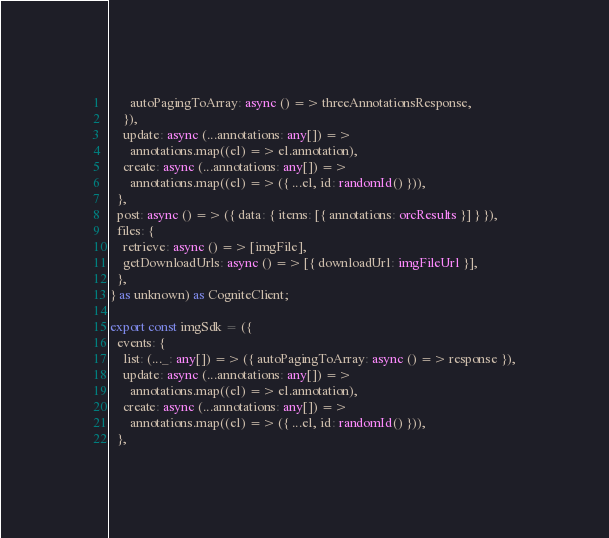<code> <loc_0><loc_0><loc_500><loc_500><_TypeScript_>      autoPagingToArray: async () => threeAnnotationsResponse,
    }),
    update: async (...annotations: any[]) =>
      annotations.map((el) => el.annotation),
    create: async (...annotations: any[]) =>
      annotations.map((el) => ({ ...el, id: randomId() })),
  },
  post: async () => ({ data: { items: [{ annotations: orcResults }] } }),
  files: {
    retrieve: async () => [imgFile],
    getDownloadUrls: async () => [{ downloadUrl: imgFileUrl }],
  },
} as unknown) as CogniteClient;

export const imgSdk = ({
  events: {
    list: (..._: any[]) => ({ autoPagingToArray: async () => response }),
    update: async (...annotations: any[]) =>
      annotations.map((el) => el.annotation),
    create: async (...annotations: any[]) =>
      annotations.map((el) => ({ ...el, id: randomId() })),
  },</code> 